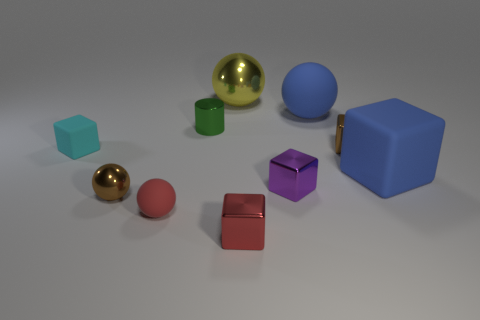Subtract all small brown cubes. How many cubes are left? 4 Subtract all red spheres. How many spheres are left? 3 Subtract 1 blue cubes. How many objects are left? 9 Subtract all cylinders. How many objects are left? 9 Subtract 2 spheres. How many spheres are left? 2 Subtract all red blocks. Subtract all blue balls. How many blocks are left? 4 Subtract all green cylinders. How many blue spheres are left? 1 Subtract all tiny gray things. Subtract all blocks. How many objects are left? 5 Add 1 large blue objects. How many large blue objects are left? 3 Add 3 rubber objects. How many rubber objects exist? 7 